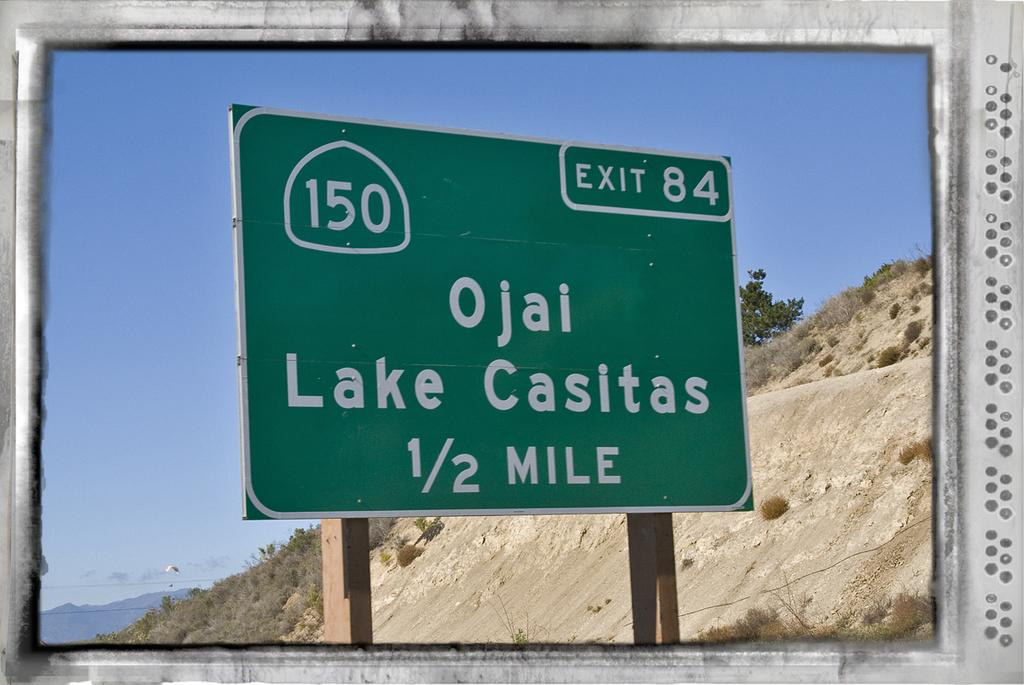Provide a one-sentence caption for the provided image. The green sign says that exit 84 is in half a mile. 